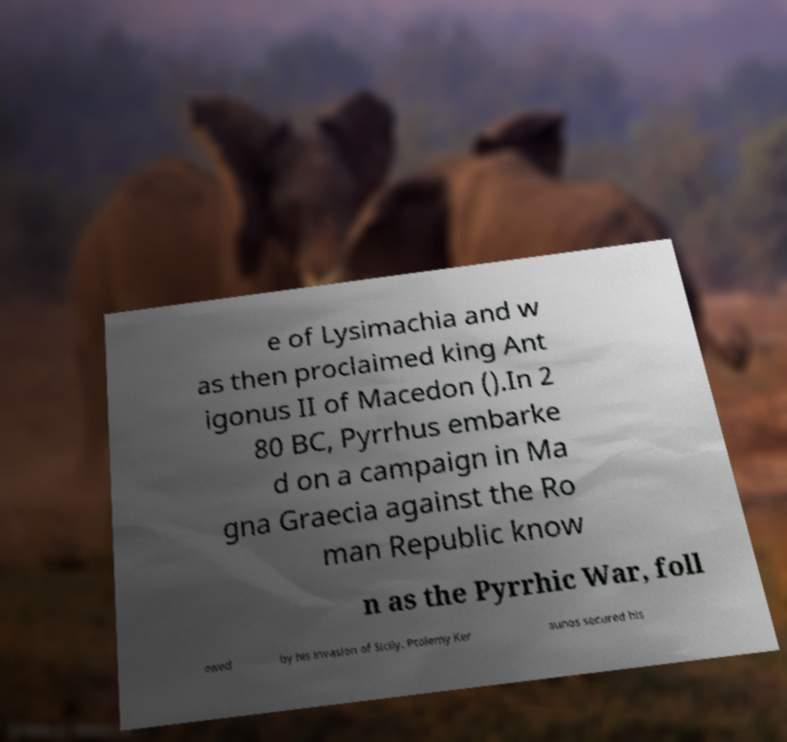For documentation purposes, I need the text within this image transcribed. Could you provide that? e of Lysimachia and w as then proclaimed king Ant igonus II of Macedon ().In 2 80 BC, Pyrrhus embarke d on a campaign in Ma gna Graecia against the Ro man Republic know n as the Pyrrhic War, foll owed by his invasion of Sicily. Ptolemy Ker aunos secured his 